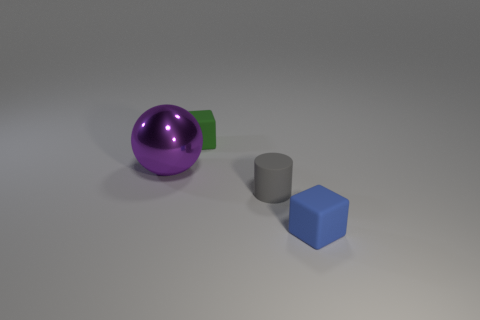Subtract 1 cylinders. How many cylinders are left? 0 Add 4 purple metallic balls. How many objects exist? 8 Subtract 0 blue spheres. How many objects are left? 4 Subtract all spheres. How many objects are left? 3 Subtract all purple cylinders. Subtract all purple spheres. How many cylinders are left? 1 Subtract all small brown cylinders. Subtract all tiny rubber things. How many objects are left? 1 Add 1 green rubber cubes. How many green rubber cubes are left? 2 Add 4 large shiny spheres. How many large shiny spheres exist? 5 